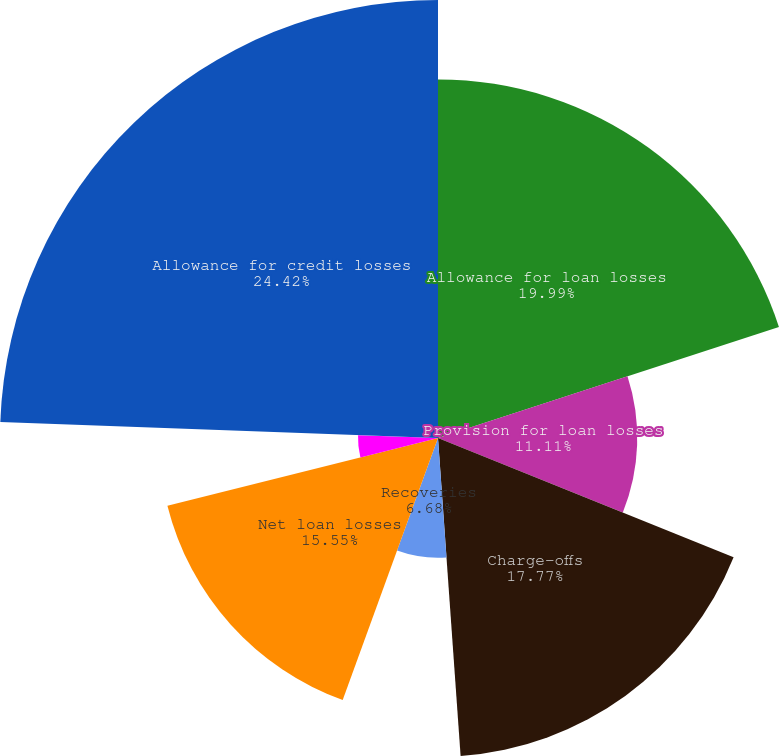Convert chart to OTSL. <chart><loc_0><loc_0><loc_500><loc_500><pie_chart><fcel>Allowance for loan losses<fcel>Provision for loan losses<fcel>Charge-offs<fcel>Recoveries<fcel>Net loan losses<fcel>Reserve for unfunded credit<fcel>Provision (credit) for<fcel>Allowance for credit losses<nl><fcel>19.99%<fcel>11.11%<fcel>17.77%<fcel>6.68%<fcel>15.55%<fcel>4.46%<fcel>0.02%<fcel>24.42%<nl></chart> 